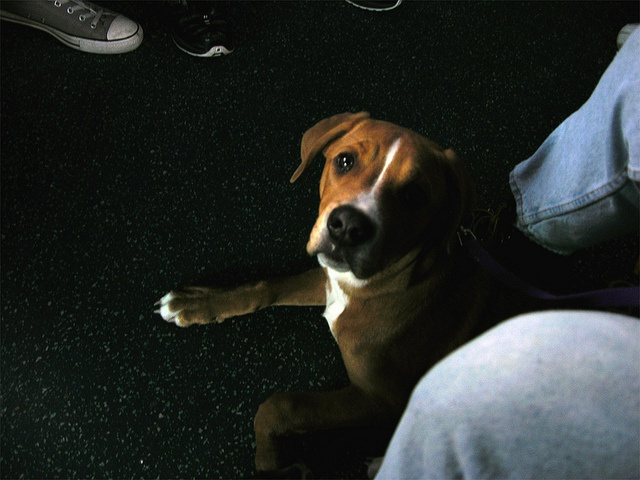Describe the objects in this image and their specific colors. I can see people in black, darkgray, and gray tones, dog in black, maroon, and brown tones, people in black and gray tones, and people in black, gray, and darkgray tones in this image. 